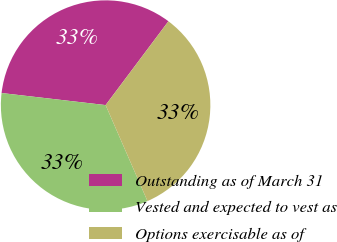<chart> <loc_0><loc_0><loc_500><loc_500><pie_chart><fcel>Outstanding as of March 31<fcel>Vested and expected to vest as<fcel>Options exercisable as of<nl><fcel>33.4%<fcel>33.38%<fcel>33.22%<nl></chart> 